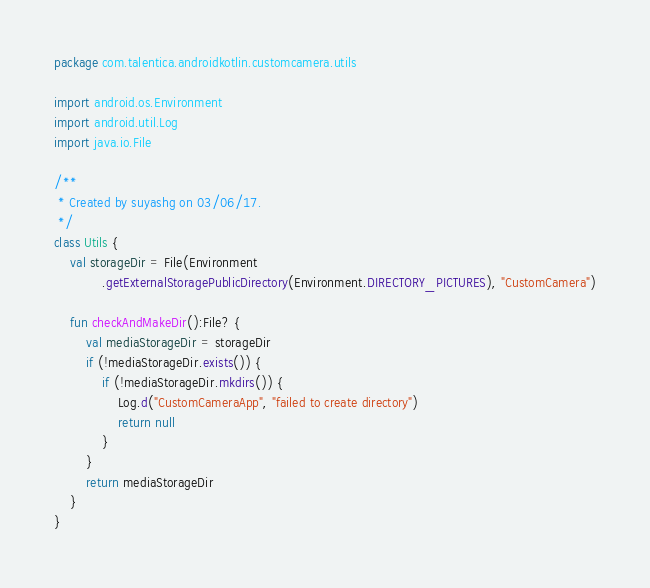Convert code to text. <code><loc_0><loc_0><loc_500><loc_500><_Kotlin_>package com.talentica.androidkotlin.customcamera.utils

import android.os.Environment
import android.util.Log
import java.io.File

/**
 * Created by suyashg on 03/06/17.
 */
class Utils {
    val storageDir = File(Environment
            .getExternalStoragePublicDirectory(Environment.DIRECTORY_PICTURES), "CustomCamera")

    fun checkAndMakeDir():File? {
        val mediaStorageDir = storageDir
        if (!mediaStorageDir.exists()) {
            if (!mediaStorageDir.mkdirs()) {
                Log.d("CustomCameraApp", "failed to create directory")
                return null
            }
        }
        return mediaStorageDir
    }
}</code> 